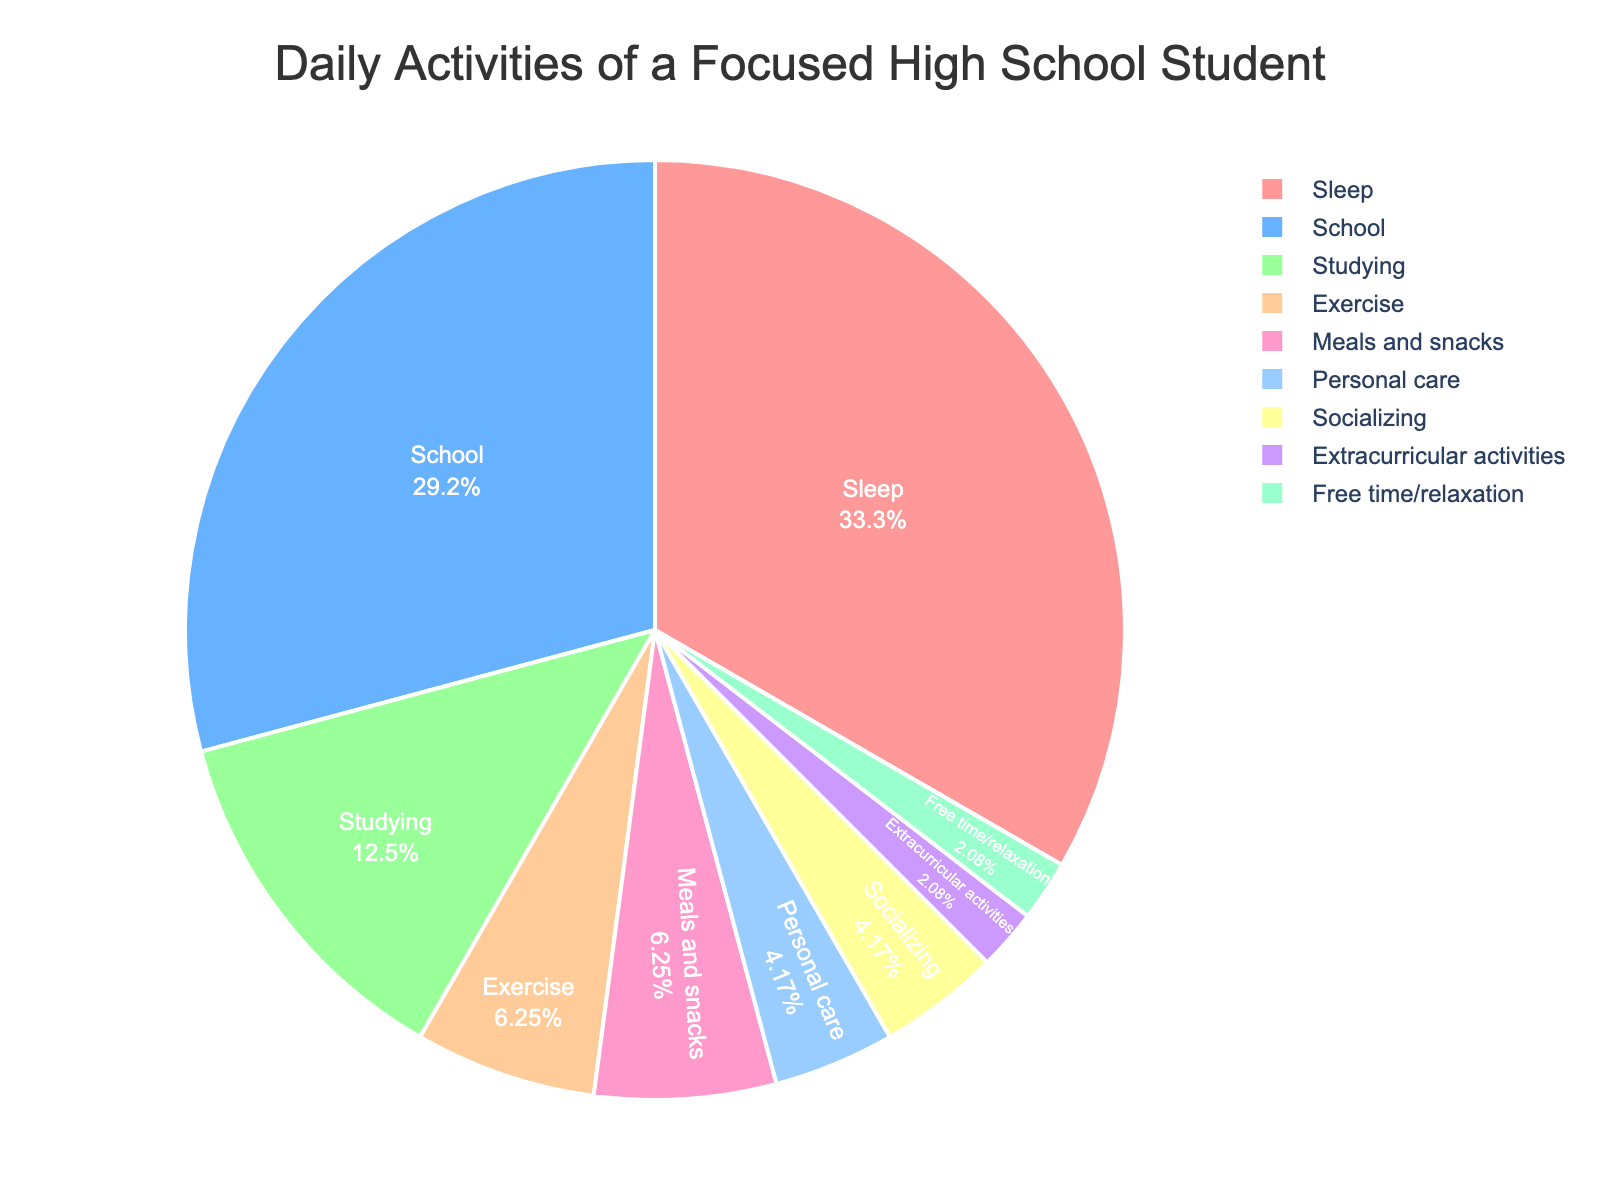what activity takes up the most time for the student? By looking at the pie chart, the largest segment represents the activity that takes up the most time.
Answer: Sleep How much time in total does the student spend on studying and exercising? Add the hours spent on studying (3) and exercising (1.5) together. 3 + 1.5 = 4.5
Answer: 4.5 hours Which activity takes up more time, socializing or personal care? By referring to the pie chart, compare the sizes of the segments for socializing and personal care. Personal care is larger and has 1 hour, whereas socializing has 1 hour. The time is actually equal.
Answer: Personal care and socializing take up the same amount of time What percentage of their day does the student spend on school activities (school and studying combined)? Add the hours spent on school (7) and studying (3), which is 7 + 3 = 10. Then, calculate the percentage by dividing by the total hours available in a day (24) and multiplying by 100. (10 / 24) * 100 ≈ 41.67%
Answer: Approximately 41.67% What is the least time-consuming activity on the chart? Identify the smallest segment in the pie chart to find the least time-consuming activity.
Answer: Extracurricular activities Which is the largest non-school-related activity? Exclude school-related activities (school and studying) and compare the remaining activities to find the largest. The largest segment outside school-related activities is Sleep.
Answer: Sleep How much more time does the student spend on sleep compared to exercise? Subtract the hours spent on exercise from the hours spent on sleep. 8 - 1.5 = 6.5
Answer: 6.5 hours What is the combined duration of meals, personal care, and socializing? Sum the hours spent on meals and snacks (1.5), personal care (1), and socializing (1). 1.5 + 1 + 1 = 3.5
Answer: 3.5 hours Is the time allocated for extracurricular activities greater or less than the time allocated for free time/relaxation? Compare the sizes of the pie chart segments for extracurricular activities and free time/relaxation. Both extracurricular activities and free time/relaxation are shown to have 0.5 hours.
Answer: Equal How many hours in total does the student spend on activities other than sleeping and schooling? Subtract the combined hours spent on sleep and school from 24. Sleep + school = 8 + 7 = 15, so 24 - 15 = 9
Answer: 9 hours 